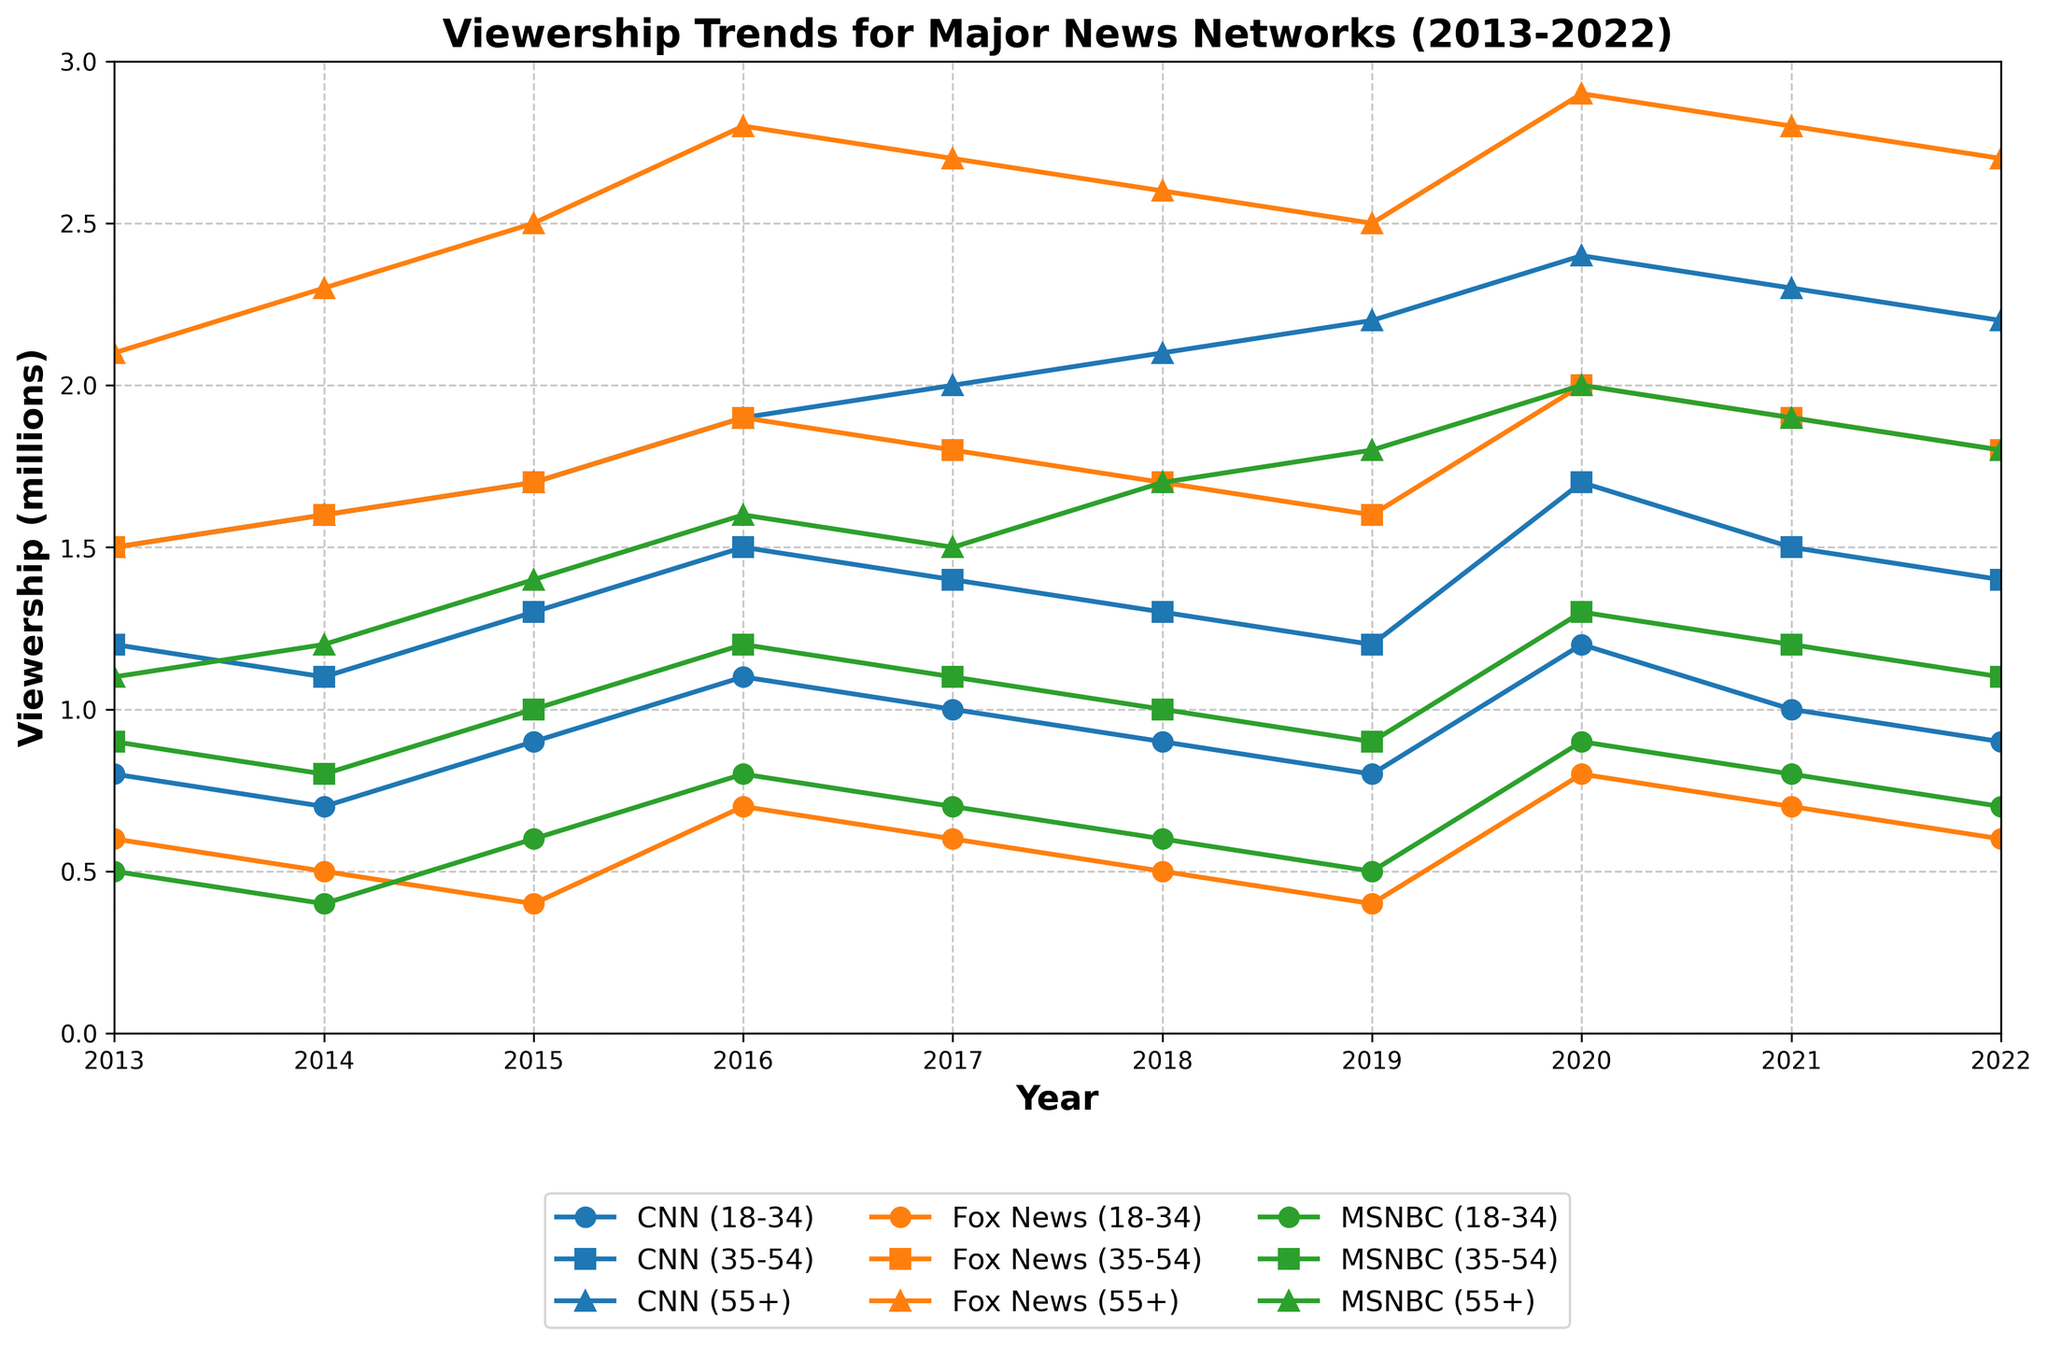Which age group had the highest viewership for CNN in 2020? Look at the viewership values for CNN in 2020 across age groups. The values are 1.2 (18-34), 1.7 (35-54), and 2.4 (55+). The highest value is 2.4 for the 55+ age group.
Answer: 55+ What was the total viewership of Fox News across all age groups in 2016? Sum the viewership values for Fox News in 2016 across all age groups: 0.7 (18-34) + 1.9 (35-54) + 2.8 (55+). The total is 0.7 + 1.9 + 2.8 = 5.4 million.
Answer: 5.4 million Between 2015 and 2020, which age group showed the most significant increase in MSNBC viewership? Calculate the difference in MSNBC viewership values between 2015 and 2020 for each age group: (2020 value - 2015 value). For 18-34: 0.9 - 0.6 = 0.3 million. For 35-54: 1.3 - 1.0 = 0.3 million. For 55+: 2.0 - 1.4 = 0.6 million. The 55+ age group showed the most significant increase.
Answer: 55+ Comparing 2017, which network had the highest viewership for the 35-54 age group? Check the viewership values for each network in 2017 for the 35-54 age group: CNN (1.4), Fox News (1.8), and MSNBC (1.1). The highest value is 1.8 for Fox News.
Answer: Fox News What is the average viewership for the 18-34 age group across all networks in 2018? Calculate the average viewership by summing the 2018 values for all networks in the 18-34 age group and dividing by the number of networks: (0.9 + 0.5 + 0.6) / 3 = 2.0 / 3 ≈ 0.67 million.
Answer: 0.67 million In 2021, did any network have equal viewership in the 18-34 and 35-54 age groups? Compare the 2021 viewership values for each network between the 18-34 and 35-54 age groups. CNN: 18-34 (1.0) vs. 35-54 (1.5), Fox News: 18-34 (0.7) vs. 35-54 (1.9), MSNBC: 18-34 (0.8) vs. 35-54 (1.2). None have equal values.
Answer: No By how much did CNN viewership for the 55+ age group increase from 2014 to 2020? Calculate the difference in CNN viewership values for the 55+ age group between 2014 and 2020: 2.4 - 1.6 = 0.8 million.
Answer: 0.8 million Which network had the lowest viewership among the 18-34 age group in 2019? Check the viewership values for each network in the 18-34 age group in 2019: CNN (0.8), Fox News (0.4), and MSNBC (0.5). The lowest value is 0.4 for Fox News.
Answer: Fox News Comparing 2015 and 2018, which network had a decline in viewership for the 35-54 age group? Check the viewership values for each network in the 35-54 age group between 2015 and 2018. CNN: 1.3 (2015) vs. 1.3 (2018) — no change. Fox News: 1.7 (2015) vs. 1.7 (2018) — no change. MSNBC: 1.0 (2015) vs. 1.0 (2018) — no change. There is no decline observed.
Answer: None What was the trend in viewership for Fox News among the 55+ age group from 2013 to 2022? Observe and summarize the viewership values for Fox News in the 55+ age group: 2.1 (2013), 2.3 (2014), 2.5 (2015), 2.8 (2016), 2.7 (2017), 2.6 (2018), 2.5 (2019), 2.9 (2020), 2.8 (2021), 2.7 (2022). The trend shows an overall slight increase with some fluctuations.
Answer: Slight increase with fluctuations 